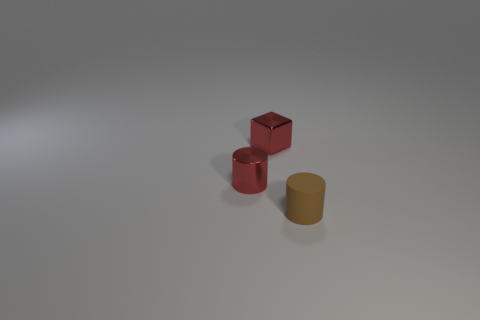What color is the cylinder in front of the small red thing in front of the red metal object behind the tiny red metal cylinder?
Your answer should be very brief. Brown. The cylinder that is the same size as the brown thing is what color?
Offer a terse response. Red. What shape is the small red metallic object that is in front of the metallic thing that is behind the red shiny thing that is in front of the small red cube?
Offer a terse response. Cylinder. What shape is the metal thing that is the same color as the metallic block?
Offer a terse response. Cylinder. How many things are either big green cylinders or cylinders right of the tiny shiny cylinder?
Offer a terse response. 1. There is a cylinder that is in front of the red shiny cylinder; does it have the same size as the small red cylinder?
Give a very brief answer. Yes. What is the material of the tiny red thing on the right side of the red metal cylinder?
Your response must be concise. Metal. Are there the same number of red shiny things in front of the matte thing and red cylinders that are to the right of the red shiny cylinder?
Your answer should be very brief. Yes. What color is the other tiny thing that is the same shape as the tiny matte object?
Your response must be concise. Red. Are there any other things that are the same color as the small rubber cylinder?
Provide a short and direct response. No. 